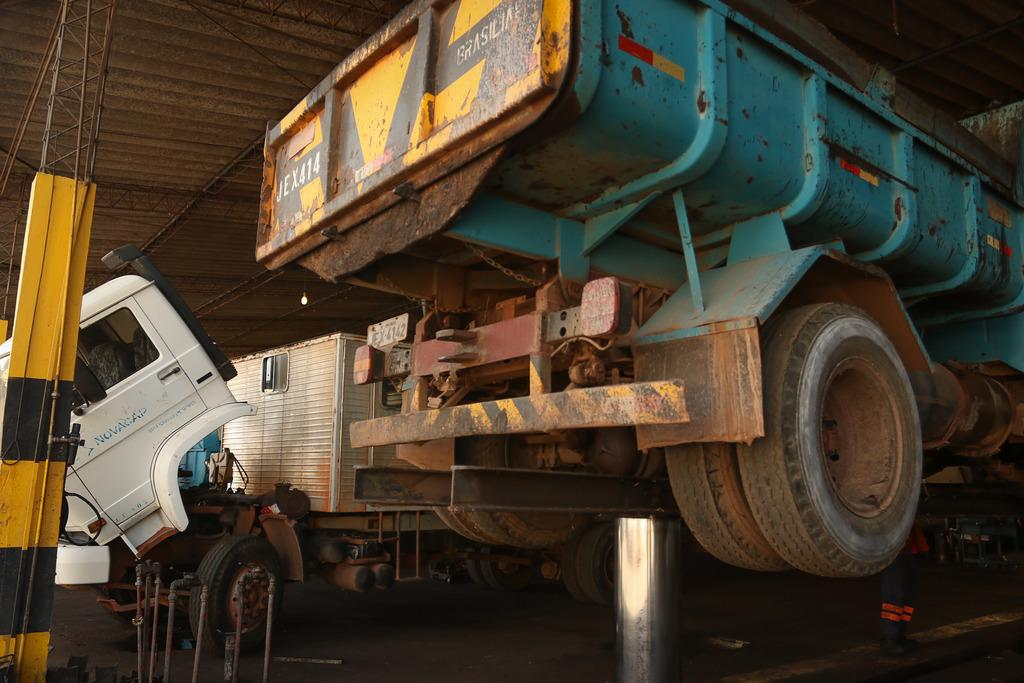What type of objects can be seen in the image? There are vehicles in the image. What can be seen in the background of the image? There is a wall and lights on the ceiling in the background of the image. Are there any other objects visible in the background? Yes, there are other objects visible in the background of the image. What riddle is being solved by the vehicles in the image? There is no riddle being solved by the vehicles in the image; they are simply objects in the scene. 